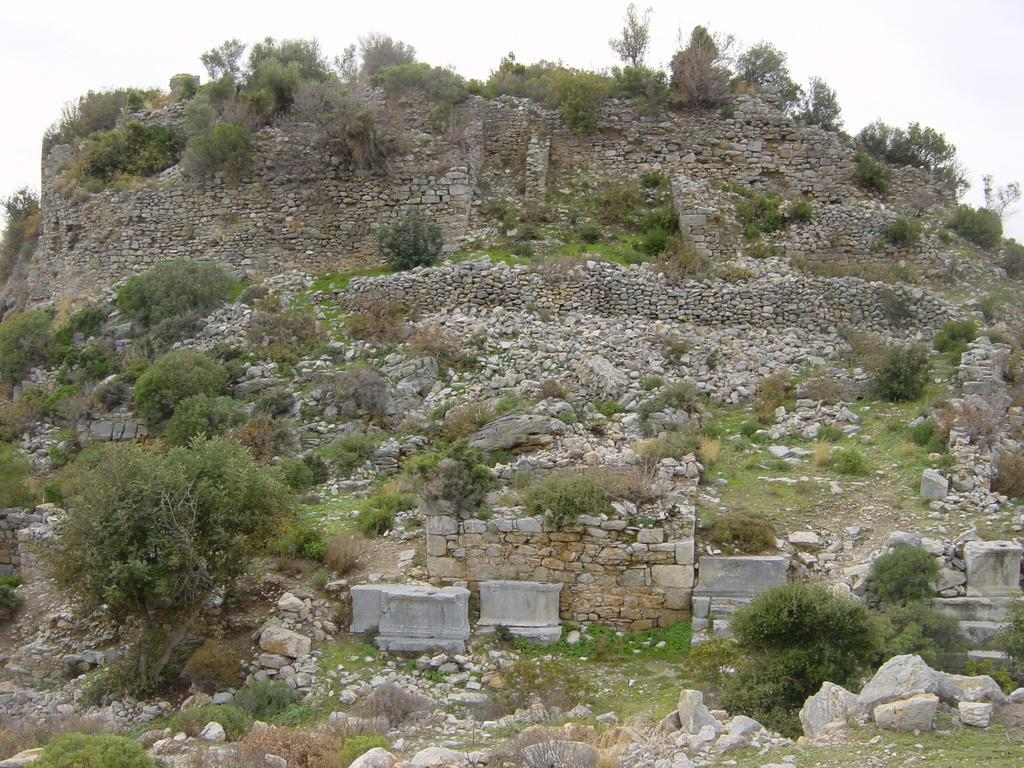What type of landform is present in the image? There is a hill in the image. What type of natural objects can be seen on the hill? There are stones, rocks, bushes, shrubs, and trees in the image. Where is the box located in the image? There is no box present in the image. What type of creature can be seen sneezing in the image? There is no creature present in the image, and therefore no sneezing can be observed. --- Facts: 1. There is a person in the image. 2. The person is wearing a hat. 3. The person is holding a book. 4. There is a table in the image. 5. The table has a lamp on it. Absurd Topics: parrot, bicycle, ocean Conversation: What is the main subject of the image? The main subject of the image is a person. What is the person wearing in the image? The person is wearing a hat. What is the person holding in the image? The person is holding a book. What type of furniture is present in the image? There is a table in the image. What object is on the table in the image? The table has a lamp on it. Reasoning: Let's think step by step in order to produce the conversation. We start by identifying the main subject of the image, which is the person. Then, we describe the person's attire and what they are holding, which is a hat and a book, respectively. Next, we identify the furniture present in the image, which is a table. Finally, we describe the object on the table, which is a lamp. Each question is designed to elicit a specific detail about the image that is known from the provided facts. Absurd Question/Answer: Can you see a parrot flying over the ocean in the image? There is no parrot or ocean present in the image. What type of vehicle is the person riding in the image? There is no vehicle present in the image; the person is standing. --- Facts: 1. There is a person in the image. 2. The person is holding a camera. 3. There is a building in the background of the image. 4. There are trees in the background of the image. 5. The sky is visible in the background of the image. Absurd Topics: elephant, piano, rainbow Conversation: What is the main subject of the image? The main subject of the image is a person. What is the person holding in the image? The person is holding a camera. What can be seen in the background of the image? There is a building, trees, and the sky visible in the background of the image. Reasoning: Let's think step by 